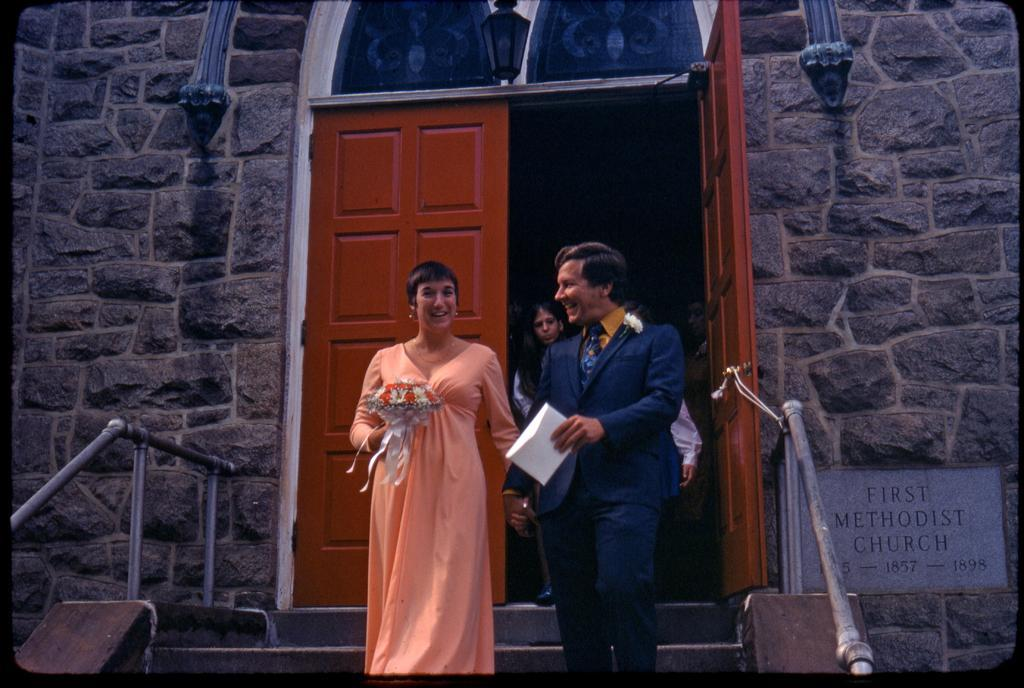What are the people in the image doing? The persons in the image are on a staircase. What can be seen in the background of the image? There is a street light, a door, a wall with cobblestones, and a railing in the background of the image. How many cacti are visible in the image? There are no cacti present in the image. What time does the clock show in the image? There is no clock present in the image. 